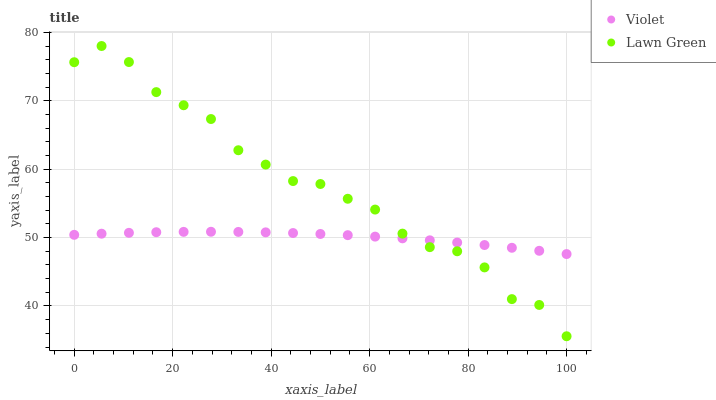Does Violet have the minimum area under the curve?
Answer yes or no. Yes. Does Lawn Green have the maximum area under the curve?
Answer yes or no. Yes. Does Violet have the maximum area under the curve?
Answer yes or no. No. Is Violet the smoothest?
Answer yes or no. Yes. Is Lawn Green the roughest?
Answer yes or no. Yes. Is Violet the roughest?
Answer yes or no. No. Does Lawn Green have the lowest value?
Answer yes or no. Yes. Does Violet have the lowest value?
Answer yes or no. No. Does Lawn Green have the highest value?
Answer yes or no. Yes. Does Violet have the highest value?
Answer yes or no. No. Does Lawn Green intersect Violet?
Answer yes or no. Yes. Is Lawn Green less than Violet?
Answer yes or no. No. Is Lawn Green greater than Violet?
Answer yes or no. No. 